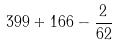<formula> <loc_0><loc_0><loc_500><loc_500>3 9 9 + 1 6 6 - \frac { 2 } { 6 2 }</formula> 